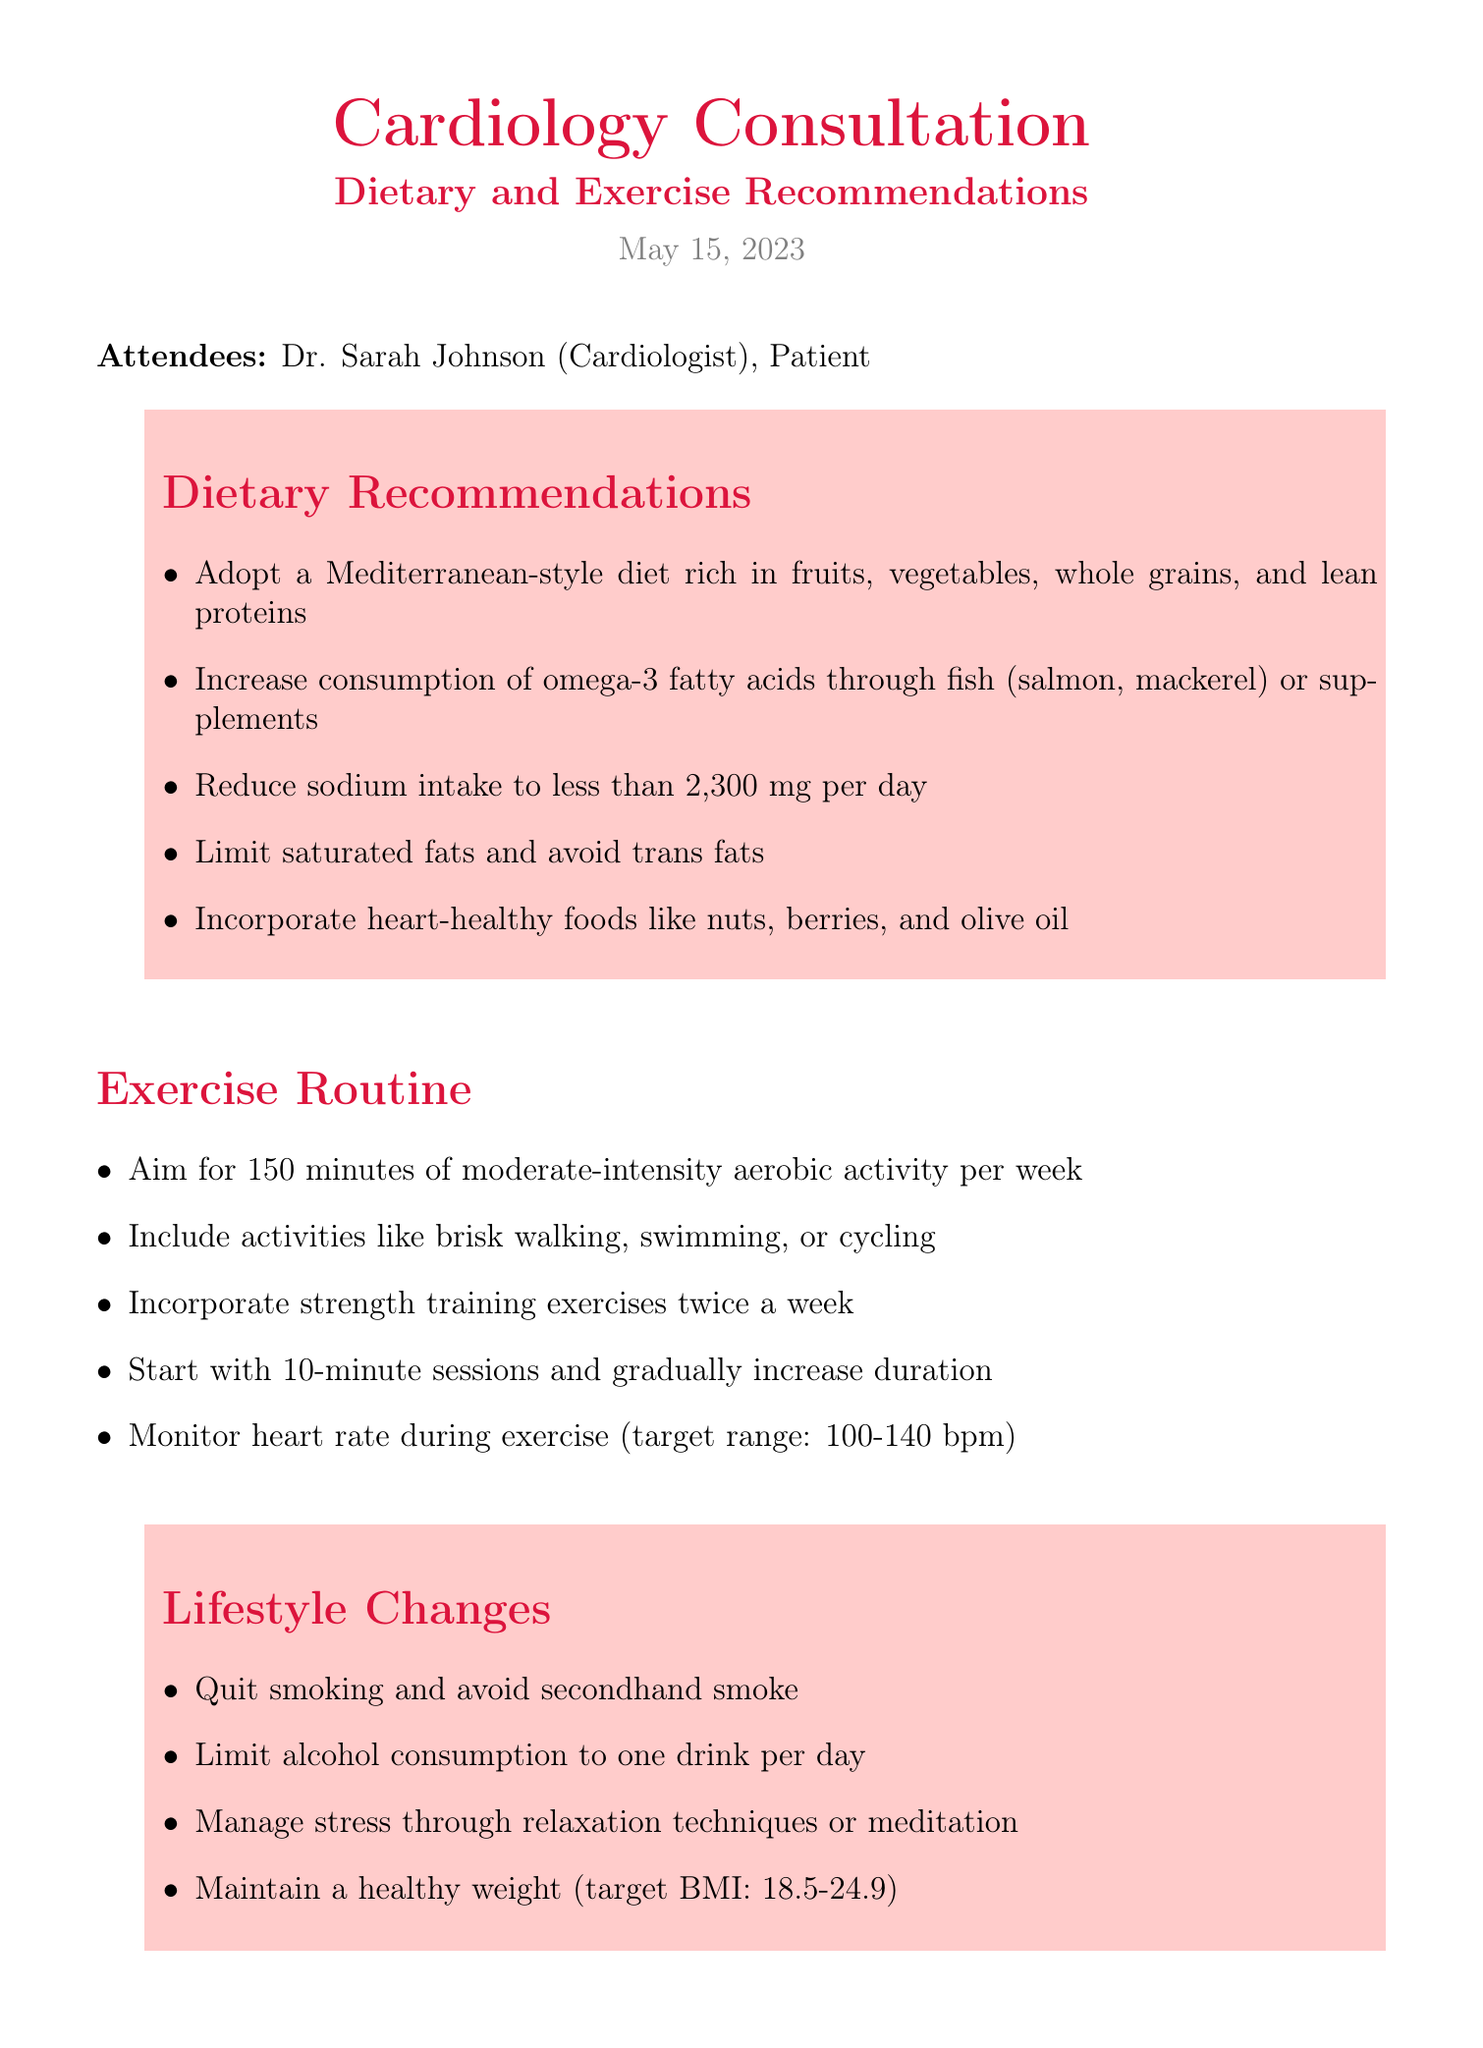What is the title of the meeting? The title of the meeting is stated at the beginning of the document.
Answer: Cardiology Consultation: Dietary and Exercise Recommendations Who is the cardiologist present at the consultation? The document lists the attendees, including the cardiologist's name.
Answer: Dr. Sarah Johnson What is the recommended sodium intake per day? The document specifies the reduced sodium intake as part of dietary recommendations.
Answer: less than 2,300 mg How many minutes of aerobic activity per week does the exercise routine recommend? The exercise routine section includes a specific amount of aerobic activity per week.
Answer: 150 minutes What type of diet is recommended? The dietary recommendations section mentions a specific diet type to adopt.
Answer: Mediterranean-style diet How often should strength training be incorporated? The exercise routine details how often strength training exercises should be included.
Answer: twice a week What is the target BMI mentioned for maintaining a healthy weight? The lifestyle changes section indicates the target BMI for weight management.
Answer: 18.5-24.9 What should the patient do before the follow-up appointment? The follow-up section outlines actions that should be taken prior to the next appointment.
Answer: Keep a food and exercise diary What organization is listed as an additional resource? The additional resources section names an organization providing heart health information.
Answer: American Heart Association 